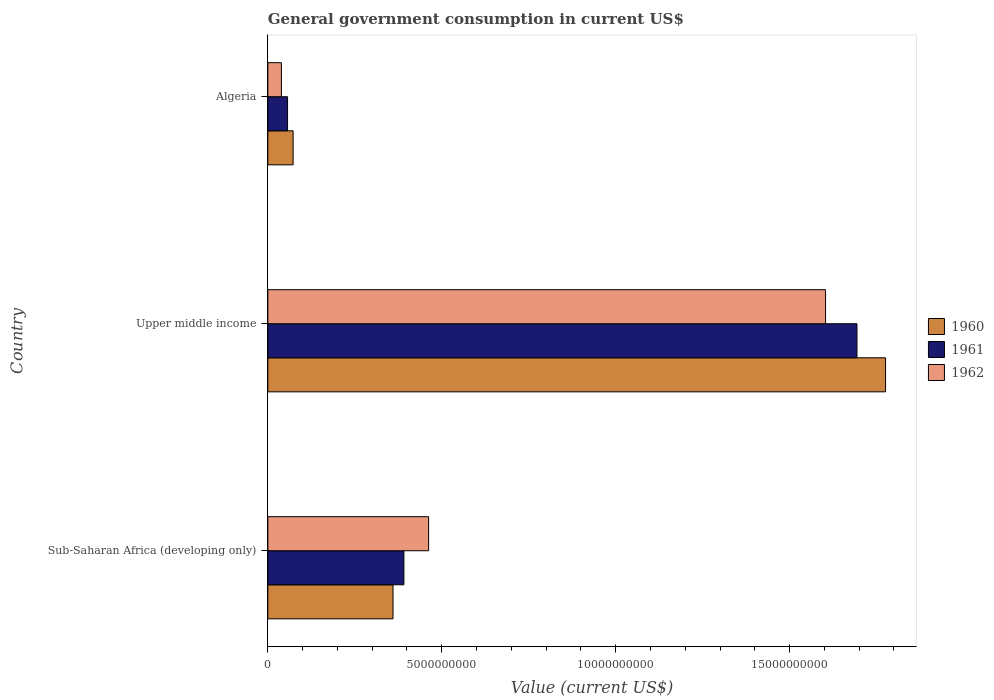How many different coloured bars are there?
Your answer should be compact. 3. How many groups of bars are there?
Your response must be concise. 3. Are the number of bars per tick equal to the number of legend labels?
Offer a terse response. Yes. How many bars are there on the 1st tick from the top?
Provide a succinct answer. 3. How many bars are there on the 1st tick from the bottom?
Give a very brief answer. 3. What is the label of the 2nd group of bars from the top?
Offer a very short reply. Upper middle income. What is the government conusmption in 1962 in Upper middle income?
Ensure brevity in your answer.  1.60e+1. Across all countries, what is the maximum government conusmption in 1962?
Ensure brevity in your answer.  1.60e+1. Across all countries, what is the minimum government conusmption in 1962?
Make the answer very short. 3.90e+08. In which country was the government conusmption in 1962 maximum?
Provide a short and direct response. Upper middle income. In which country was the government conusmption in 1960 minimum?
Provide a succinct answer. Algeria. What is the total government conusmption in 1960 in the graph?
Provide a short and direct response. 2.21e+1. What is the difference between the government conusmption in 1962 in Sub-Saharan Africa (developing only) and that in Upper middle income?
Ensure brevity in your answer.  -1.14e+1. What is the difference between the government conusmption in 1962 in Algeria and the government conusmption in 1960 in Upper middle income?
Your answer should be very brief. -1.74e+1. What is the average government conusmption in 1962 per country?
Provide a short and direct response. 7.01e+09. What is the difference between the government conusmption in 1960 and government conusmption in 1961 in Sub-Saharan Africa (developing only)?
Make the answer very short. -3.13e+08. What is the ratio of the government conusmption in 1960 in Sub-Saharan Africa (developing only) to that in Upper middle income?
Give a very brief answer. 0.2. What is the difference between the highest and the second highest government conusmption in 1961?
Your answer should be compact. 1.30e+1. What is the difference between the highest and the lowest government conusmption in 1960?
Make the answer very short. 1.70e+1. How many bars are there?
Give a very brief answer. 9. Are all the bars in the graph horizontal?
Keep it short and to the point. Yes. What is the difference between two consecutive major ticks on the X-axis?
Keep it short and to the point. 5.00e+09. Does the graph contain grids?
Offer a terse response. No. Where does the legend appear in the graph?
Give a very brief answer. Center right. How many legend labels are there?
Offer a very short reply. 3. What is the title of the graph?
Make the answer very short. General government consumption in current US$. Does "1960" appear as one of the legend labels in the graph?
Keep it short and to the point. Yes. What is the label or title of the X-axis?
Offer a very short reply. Value (current US$). What is the label or title of the Y-axis?
Provide a succinct answer. Country. What is the Value (current US$) of 1960 in Sub-Saharan Africa (developing only)?
Provide a short and direct response. 3.60e+09. What is the Value (current US$) of 1961 in Sub-Saharan Africa (developing only)?
Provide a short and direct response. 3.91e+09. What is the Value (current US$) of 1962 in Sub-Saharan Africa (developing only)?
Offer a very short reply. 4.62e+09. What is the Value (current US$) of 1960 in Upper middle income?
Provide a short and direct response. 1.78e+1. What is the Value (current US$) of 1961 in Upper middle income?
Keep it short and to the point. 1.69e+1. What is the Value (current US$) of 1962 in Upper middle income?
Your answer should be compact. 1.60e+1. What is the Value (current US$) of 1960 in Algeria?
Your answer should be very brief. 7.26e+08. What is the Value (current US$) of 1961 in Algeria?
Your answer should be very brief. 5.67e+08. What is the Value (current US$) in 1962 in Algeria?
Offer a terse response. 3.90e+08. Across all countries, what is the maximum Value (current US$) of 1960?
Keep it short and to the point. 1.78e+1. Across all countries, what is the maximum Value (current US$) in 1961?
Provide a short and direct response. 1.69e+1. Across all countries, what is the maximum Value (current US$) of 1962?
Provide a succinct answer. 1.60e+1. Across all countries, what is the minimum Value (current US$) in 1960?
Keep it short and to the point. 7.26e+08. Across all countries, what is the minimum Value (current US$) of 1961?
Provide a succinct answer. 5.67e+08. Across all countries, what is the minimum Value (current US$) of 1962?
Offer a terse response. 3.90e+08. What is the total Value (current US$) in 1960 in the graph?
Offer a terse response. 2.21e+1. What is the total Value (current US$) of 1961 in the graph?
Offer a terse response. 2.14e+1. What is the total Value (current US$) of 1962 in the graph?
Ensure brevity in your answer.  2.10e+1. What is the difference between the Value (current US$) of 1960 in Sub-Saharan Africa (developing only) and that in Upper middle income?
Your answer should be compact. -1.42e+1. What is the difference between the Value (current US$) of 1961 in Sub-Saharan Africa (developing only) and that in Upper middle income?
Keep it short and to the point. -1.30e+1. What is the difference between the Value (current US$) in 1962 in Sub-Saharan Africa (developing only) and that in Upper middle income?
Your answer should be compact. -1.14e+1. What is the difference between the Value (current US$) in 1960 in Sub-Saharan Africa (developing only) and that in Algeria?
Offer a terse response. 2.87e+09. What is the difference between the Value (current US$) in 1961 in Sub-Saharan Africa (developing only) and that in Algeria?
Offer a very short reply. 3.34e+09. What is the difference between the Value (current US$) of 1962 in Sub-Saharan Africa (developing only) and that in Algeria?
Give a very brief answer. 4.23e+09. What is the difference between the Value (current US$) of 1960 in Upper middle income and that in Algeria?
Offer a very short reply. 1.70e+1. What is the difference between the Value (current US$) in 1961 in Upper middle income and that in Algeria?
Keep it short and to the point. 1.64e+1. What is the difference between the Value (current US$) in 1962 in Upper middle income and that in Algeria?
Ensure brevity in your answer.  1.56e+1. What is the difference between the Value (current US$) in 1960 in Sub-Saharan Africa (developing only) and the Value (current US$) in 1961 in Upper middle income?
Give a very brief answer. -1.33e+1. What is the difference between the Value (current US$) in 1960 in Sub-Saharan Africa (developing only) and the Value (current US$) in 1962 in Upper middle income?
Your answer should be compact. -1.24e+1. What is the difference between the Value (current US$) of 1961 in Sub-Saharan Africa (developing only) and the Value (current US$) of 1962 in Upper middle income?
Provide a short and direct response. -1.21e+1. What is the difference between the Value (current US$) in 1960 in Sub-Saharan Africa (developing only) and the Value (current US$) in 1961 in Algeria?
Make the answer very short. 3.03e+09. What is the difference between the Value (current US$) in 1960 in Sub-Saharan Africa (developing only) and the Value (current US$) in 1962 in Algeria?
Make the answer very short. 3.21e+09. What is the difference between the Value (current US$) of 1961 in Sub-Saharan Africa (developing only) and the Value (current US$) of 1962 in Algeria?
Keep it short and to the point. 3.52e+09. What is the difference between the Value (current US$) of 1960 in Upper middle income and the Value (current US$) of 1961 in Algeria?
Ensure brevity in your answer.  1.72e+1. What is the difference between the Value (current US$) of 1960 in Upper middle income and the Value (current US$) of 1962 in Algeria?
Make the answer very short. 1.74e+1. What is the difference between the Value (current US$) in 1961 in Upper middle income and the Value (current US$) in 1962 in Algeria?
Your answer should be compact. 1.65e+1. What is the average Value (current US$) in 1960 per country?
Provide a short and direct response. 7.36e+09. What is the average Value (current US$) of 1961 per country?
Make the answer very short. 7.14e+09. What is the average Value (current US$) of 1962 per country?
Keep it short and to the point. 7.01e+09. What is the difference between the Value (current US$) of 1960 and Value (current US$) of 1961 in Sub-Saharan Africa (developing only)?
Offer a terse response. -3.13e+08. What is the difference between the Value (current US$) in 1960 and Value (current US$) in 1962 in Sub-Saharan Africa (developing only)?
Offer a terse response. -1.02e+09. What is the difference between the Value (current US$) in 1961 and Value (current US$) in 1962 in Sub-Saharan Africa (developing only)?
Offer a terse response. -7.11e+08. What is the difference between the Value (current US$) in 1960 and Value (current US$) in 1961 in Upper middle income?
Your answer should be very brief. 8.22e+08. What is the difference between the Value (current US$) in 1960 and Value (current US$) in 1962 in Upper middle income?
Ensure brevity in your answer.  1.72e+09. What is the difference between the Value (current US$) in 1961 and Value (current US$) in 1962 in Upper middle income?
Keep it short and to the point. 9.03e+08. What is the difference between the Value (current US$) of 1960 and Value (current US$) of 1961 in Algeria?
Keep it short and to the point. 1.59e+08. What is the difference between the Value (current US$) of 1960 and Value (current US$) of 1962 in Algeria?
Give a very brief answer. 3.37e+08. What is the difference between the Value (current US$) of 1961 and Value (current US$) of 1962 in Algeria?
Offer a very short reply. 1.77e+08. What is the ratio of the Value (current US$) in 1960 in Sub-Saharan Africa (developing only) to that in Upper middle income?
Provide a succinct answer. 0.2. What is the ratio of the Value (current US$) in 1961 in Sub-Saharan Africa (developing only) to that in Upper middle income?
Provide a succinct answer. 0.23. What is the ratio of the Value (current US$) of 1962 in Sub-Saharan Africa (developing only) to that in Upper middle income?
Make the answer very short. 0.29. What is the ratio of the Value (current US$) in 1960 in Sub-Saharan Africa (developing only) to that in Algeria?
Your answer should be compact. 4.95. What is the ratio of the Value (current US$) of 1961 in Sub-Saharan Africa (developing only) to that in Algeria?
Ensure brevity in your answer.  6.9. What is the ratio of the Value (current US$) in 1962 in Sub-Saharan Africa (developing only) to that in Algeria?
Your answer should be very brief. 11.86. What is the ratio of the Value (current US$) in 1960 in Upper middle income to that in Algeria?
Ensure brevity in your answer.  24.45. What is the ratio of the Value (current US$) in 1961 in Upper middle income to that in Algeria?
Your answer should be very brief. 29.88. What is the ratio of the Value (current US$) in 1962 in Upper middle income to that in Algeria?
Your answer should be compact. 41.14. What is the difference between the highest and the second highest Value (current US$) of 1960?
Offer a very short reply. 1.42e+1. What is the difference between the highest and the second highest Value (current US$) of 1961?
Offer a very short reply. 1.30e+1. What is the difference between the highest and the second highest Value (current US$) in 1962?
Your answer should be compact. 1.14e+1. What is the difference between the highest and the lowest Value (current US$) in 1960?
Keep it short and to the point. 1.70e+1. What is the difference between the highest and the lowest Value (current US$) in 1961?
Keep it short and to the point. 1.64e+1. What is the difference between the highest and the lowest Value (current US$) in 1962?
Your answer should be very brief. 1.56e+1. 